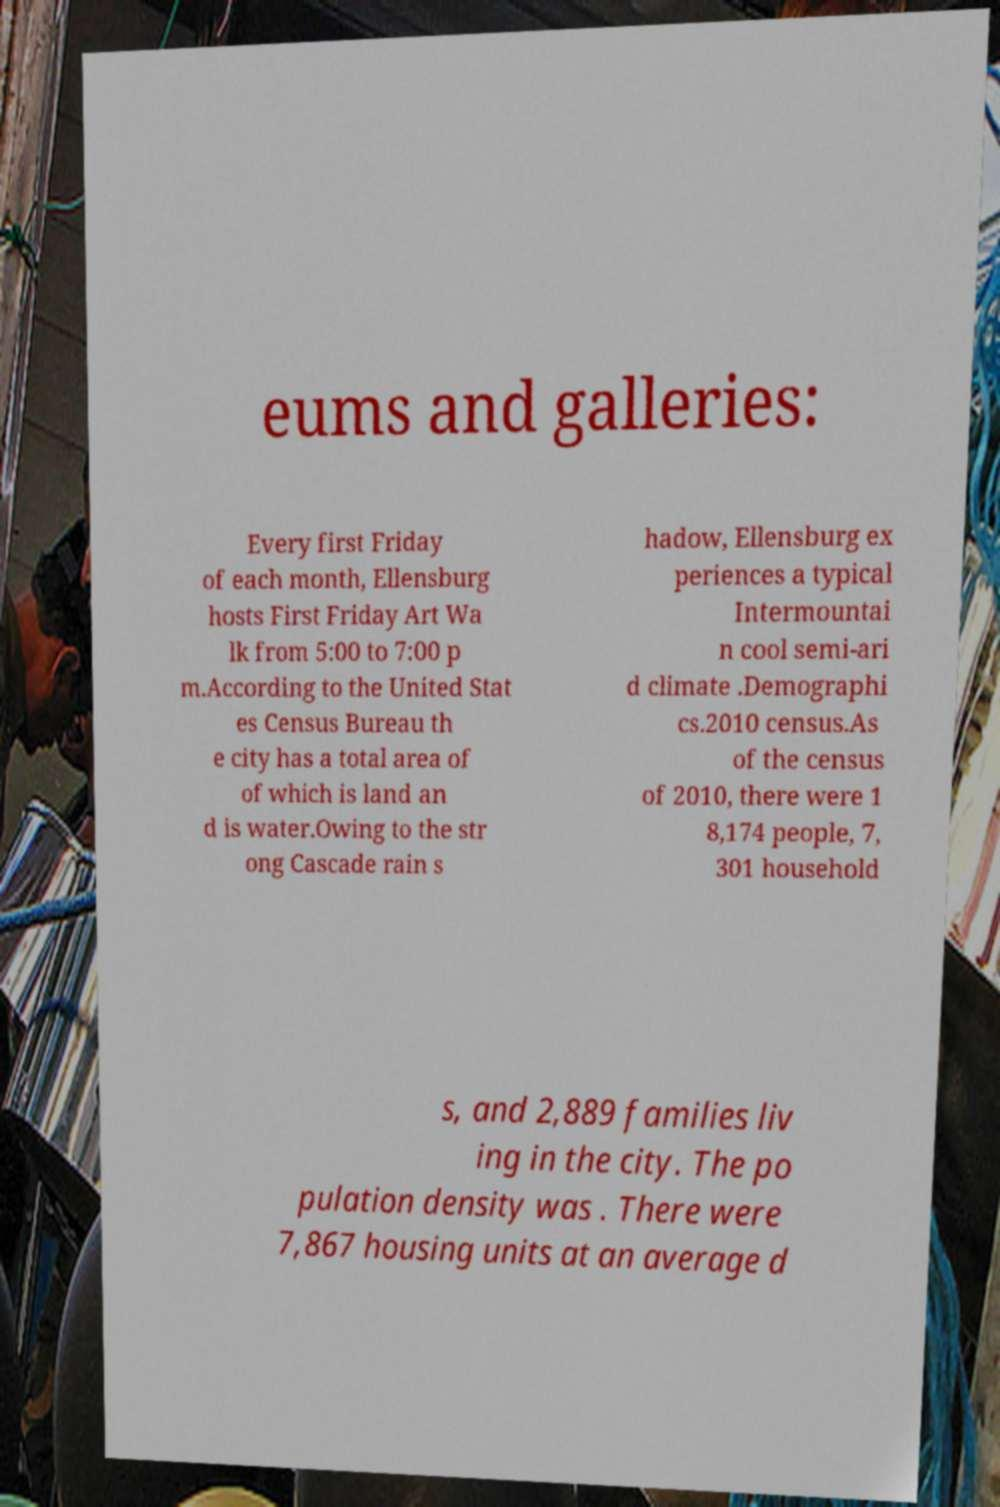There's text embedded in this image that I need extracted. Can you transcribe it verbatim? eums and galleries: Every first Friday of each month, Ellensburg hosts First Friday Art Wa lk from 5:00 to 7:00 p m.According to the United Stat es Census Bureau th e city has a total area of of which is land an d is water.Owing to the str ong Cascade rain s hadow, Ellensburg ex periences a typical Intermountai n cool semi-ari d climate .Demographi cs.2010 census.As of the census of 2010, there were 1 8,174 people, 7, 301 household s, and 2,889 families liv ing in the city. The po pulation density was . There were 7,867 housing units at an average d 